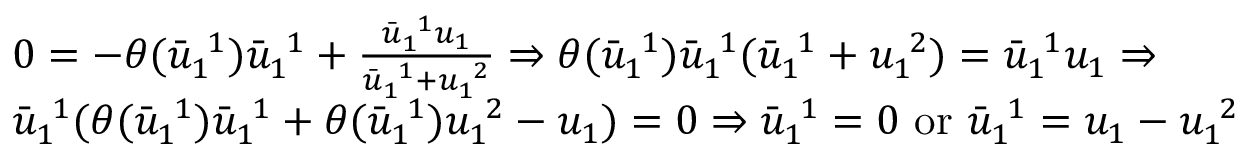<formula> <loc_0><loc_0><loc_500><loc_500>\begin{array} { r l } & { 0 = - \theta ( \bar { u } _ { 1 \ } ^ { \ 1 } ) \bar { u } _ { 1 \ } ^ { \ 1 } + \frac { \bar { u } _ { 1 \ } ^ { \ 1 } u _ { 1 } } { \bar { u } _ { 1 \ } ^ { \ 1 } + u _ { 1 \ } ^ { \ 2 } } \Rightarrow \theta ( \bar { u } _ { 1 \ } ^ { \ 1 } ) \bar { u } _ { 1 \ } ^ { \ 1 } ( \bar { u } _ { 1 \ } ^ { \ 1 } + u _ { 1 \ } ^ { \ 2 } ) = \bar { u } _ { 1 \ } ^ { \ 1 } u _ { 1 } \Rightarrow } \\ & { \bar { u } _ { 1 \ } ^ { \ 1 } ( \theta ( \bar { u } _ { 1 \ } ^ { \ 1 } ) \bar { u } _ { 1 \ } ^ { \ 1 } + \theta ( \bar { u } _ { 1 \ } ^ { \ 1 } ) u _ { 1 \ } ^ { \ 2 } - u _ { 1 } ) = 0 \Rightarrow \bar { u } _ { 1 \ } ^ { \ 1 } = 0 o r \bar { u } _ { 1 \ } ^ { \ 1 } = u _ { 1 } - u _ { 1 \ } ^ { \ 2 } } \end{array}</formula> 